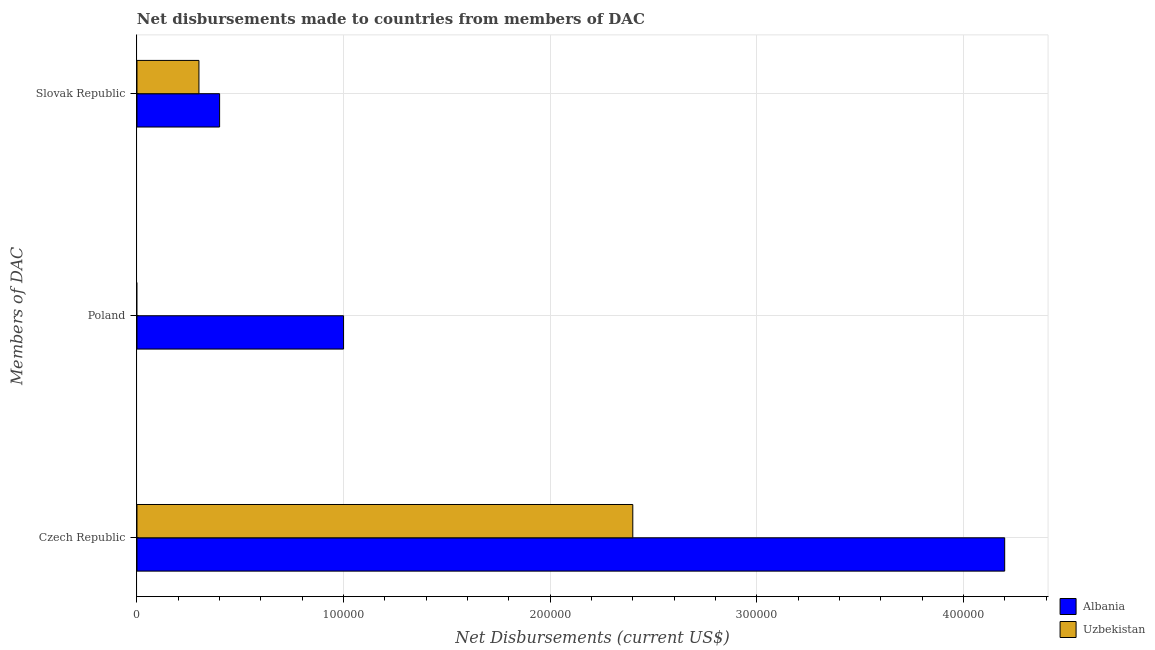How many different coloured bars are there?
Ensure brevity in your answer.  2. Are the number of bars on each tick of the Y-axis equal?
Your answer should be compact. No. What is the label of the 2nd group of bars from the top?
Offer a terse response. Poland. What is the net disbursements made by poland in Albania?
Give a very brief answer. 1.00e+05. Across all countries, what is the maximum net disbursements made by czech republic?
Offer a very short reply. 4.20e+05. Across all countries, what is the minimum net disbursements made by czech republic?
Ensure brevity in your answer.  2.40e+05. In which country was the net disbursements made by slovak republic maximum?
Offer a terse response. Albania. What is the total net disbursements made by slovak republic in the graph?
Keep it short and to the point. 7.00e+04. What is the difference between the net disbursements made by czech republic in Uzbekistan and that in Albania?
Ensure brevity in your answer.  -1.80e+05. What is the difference between the net disbursements made by czech republic in Albania and the net disbursements made by slovak republic in Uzbekistan?
Your response must be concise. 3.90e+05. What is the average net disbursements made by slovak republic per country?
Offer a very short reply. 3.50e+04. What is the difference between the net disbursements made by czech republic and net disbursements made by slovak republic in Uzbekistan?
Offer a terse response. 2.10e+05. In how many countries, is the net disbursements made by poland greater than 140000 US$?
Keep it short and to the point. 0. What is the ratio of the net disbursements made by slovak republic in Albania to that in Uzbekistan?
Your response must be concise. 1.33. Is the net disbursements made by czech republic in Albania less than that in Uzbekistan?
Give a very brief answer. No. What is the difference between the highest and the lowest net disbursements made by slovak republic?
Your answer should be very brief. 10000. Is it the case that in every country, the sum of the net disbursements made by czech republic and net disbursements made by poland is greater than the net disbursements made by slovak republic?
Ensure brevity in your answer.  Yes. Are all the bars in the graph horizontal?
Your answer should be compact. Yes. Does the graph contain any zero values?
Ensure brevity in your answer.  Yes. Does the graph contain grids?
Keep it short and to the point. Yes. How many legend labels are there?
Your answer should be very brief. 2. What is the title of the graph?
Your response must be concise. Net disbursements made to countries from members of DAC. Does "Russian Federation" appear as one of the legend labels in the graph?
Your response must be concise. No. What is the label or title of the X-axis?
Your response must be concise. Net Disbursements (current US$). What is the label or title of the Y-axis?
Ensure brevity in your answer.  Members of DAC. What is the Net Disbursements (current US$) of Albania in Czech Republic?
Give a very brief answer. 4.20e+05. What is the Net Disbursements (current US$) of Albania in Slovak Republic?
Provide a succinct answer. 4.00e+04. What is the Net Disbursements (current US$) in Uzbekistan in Slovak Republic?
Make the answer very short. 3.00e+04. Across all Members of DAC, what is the maximum Net Disbursements (current US$) of Albania?
Your answer should be compact. 4.20e+05. Across all Members of DAC, what is the minimum Net Disbursements (current US$) in Albania?
Your answer should be very brief. 4.00e+04. Across all Members of DAC, what is the minimum Net Disbursements (current US$) of Uzbekistan?
Give a very brief answer. 0. What is the total Net Disbursements (current US$) in Albania in the graph?
Keep it short and to the point. 5.60e+05. What is the total Net Disbursements (current US$) in Uzbekistan in the graph?
Keep it short and to the point. 2.70e+05. What is the difference between the Net Disbursements (current US$) of Albania in Czech Republic and that in Poland?
Your answer should be very brief. 3.20e+05. What is the difference between the Net Disbursements (current US$) in Albania in Czech Republic and that in Slovak Republic?
Your response must be concise. 3.80e+05. What is the difference between the Net Disbursements (current US$) of Uzbekistan in Czech Republic and that in Slovak Republic?
Offer a very short reply. 2.10e+05. What is the difference between the Net Disbursements (current US$) in Albania in Poland and that in Slovak Republic?
Your answer should be very brief. 6.00e+04. What is the difference between the Net Disbursements (current US$) in Albania in Czech Republic and the Net Disbursements (current US$) in Uzbekistan in Slovak Republic?
Make the answer very short. 3.90e+05. What is the difference between the Net Disbursements (current US$) in Albania in Poland and the Net Disbursements (current US$) in Uzbekistan in Slovak Republic?
Keep it short and to the point. 7.00e+04. What is the average Net Disbursements (current US$) of Albania per Members of DAC?
Offer a terse response. 1.87e+05. What is the average Net Disbursements (current US$) in Uzbekistan per Members of DAC?
Your answer should be very brief. 9.00e+04. What is the difference between the Net Disbursements (current US$) of Albania and Net Disbursements (current US$) of Uzbekistan in Czech Republic?
Provide a succinct answer. 1.80e+05. What is the ratio of the Net Disbursements (current US$) in Albania in Poland to that in Slovak Republic?
Provide a succinct answer. 2.5. What is the difference between the highest and the second highest Net Disbursements (current US$) in Albania?
Offer a terse response. 3.20e+05. What is the difference between the highest and the lowest Net Disbursements (current US$) of Albania?
Provide a short and direct response. 3.80e+05. 